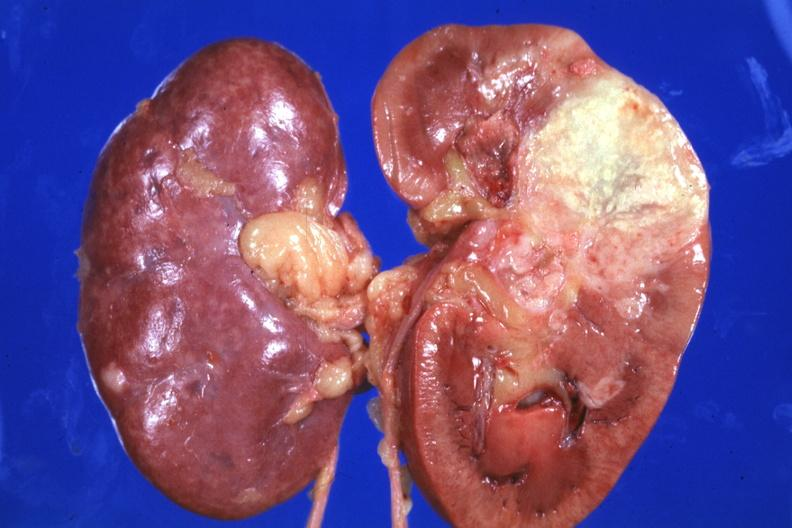s kidney present?
Answer the question using a single word or phrase. Yes 